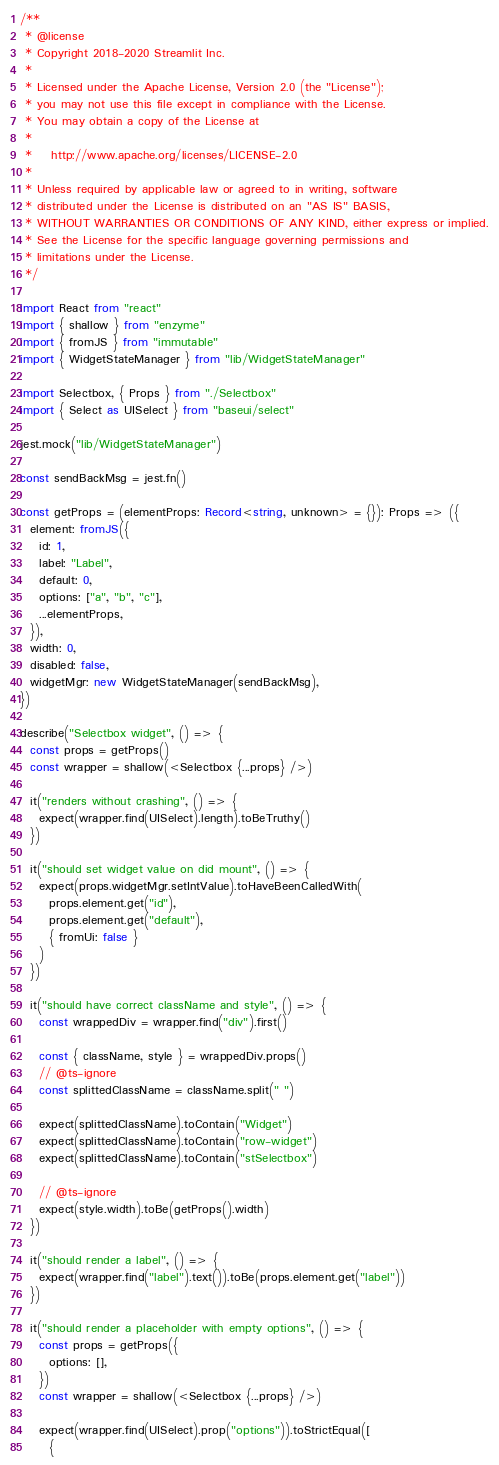Convert code to text. <code><loc_0><loc_0><loc_500><loc_500><_TypeScript_>/**
 * @license
 * Copyright 2018-2020 Streamlit Inc.
 *
 * Licensed under the Apache License, Version 2.0 (the "License");
 * you may not use this file except in compliance with the License.
 * You may obtain a copy of the License at
 *
 *    http://www.apache.org/licenses/LICENSE-2.0
 *
 * Unless required by applicable law or agreed to in writing, software
 * distributed under the License is distributed on an "AS IS" BASIS,
 * WITHOUT WARRANTIES OR CONDITIONS OF ANY KIND, either express or implied.
 * See the License for the specific language governing permissions and
 * limitations under the License.
 */

import React from "react"
import { shallow } from "enzyme"
import { fromJS } from "immutable"
import { WidgetStateManager } from "lib/WidgetStateManager"

import Selectbox, { Props } from "./Selectbox"
import { Select as UISelect } from "baseui/select"

jest.mock("lib/WidgetStateManager")

const sendBackMsg = jest.fn()

const getProps = (elementProps: Record<string, unknown> = {}): Props => ({
  element: fromJS({
    id: 1,
    label: "Label",
    default: 0,
    options: ["a", "b", "c"],
    ...elementProps,
  }),
  width: 0,
  disabled: false,
  widgetMgr: new WidgetStateManager(sendBackMsg),
})

describe("Selectbox widget", () => {
  const props = getProps()
  const wrapper = shallow(<Selectbox {...props} />)

  it("renders without crashing", () => {
    expect(wrapper.find(UISelect).length).toBeTruthy()
  })

  it("should set widget value on did mount", () => {
    expect(props.widgetMgr.setIntValue).toHaveBeenCalledWith(
      props.element.get("id"),
      props.element.get("default"),
      { fromUi: false }
    )
  })

  it("should have correct className and style", () => {
    const wrappedDiv = wrapper.find("div").first()

    const { className, style } = wrappedDiv.props()
    // @ts-ignore
    const splittedClassName = className.split(" ")

    expect(splittedClassName).toContain("Widget")
    expect(splittedClassName).toContain("row-widget")
    expect(splittedClassName).toContain("stSelectbox")

    // @ts-ignore
    expect(style.width).toBe(getProps().width)
  })

  it("should render a label", () => {
    expect(wrapper.find("label").text()).toBe(props.element.get("label"))
  })

  it("should render a placeholder with empty options", () => {
    const props = getProps({
      options: [],
    })
    const wrapper = shallow(<Selectbox {...props} />)

    expect(wrapper.find(UISelect).prop("options")).toStrictEqual([
      {</code> 